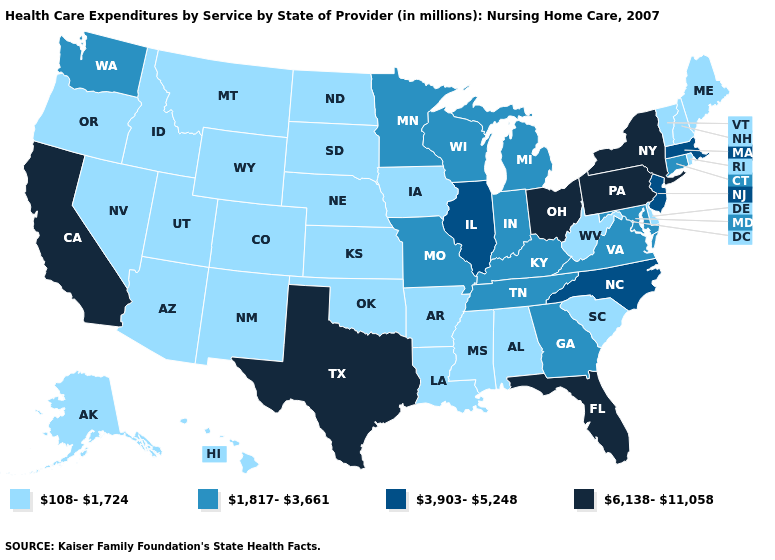Name the states that have a value in the range 6,138-11,058?
Write a very short answer. California, Florida, New York, Ohio, Pennsylvania, Texas. Which states hav the highest value in the Northeast?
Give a very brief answer. New York, Pennsylvania. Name the states that have a value in the range 3,903-5,248?
Short answer required. Illinois, Massachusetts, New Jersey, North Carolina. Does Kansas have the highest value in the MidWest?
Quick response, please. No. What is the value of Arkansas?
Quick response, please. 108-1,724. Which states have the highest value in the USA?
Give a very brief answer. California, Florida, New York, Ohio, Pennsylvania, Texas. Name the states that have a value in the range 3,903-5,248?
Write a very short answer. Illinois, Massachusetts, New Jersey, North Carolina. What is the lowest value in states that border Oklahoma?
Answer briefly. 108-1,724. Name the states that have a value in the range 1,817-3,661?
Be succinct. Connecticut, Georgia, Indiana, Kentucky, Maryland, Michigan, Minnesota, Missouri, Tennessee, Virginia, Washington, Wisconsin. Does California have the highest value in the West?
Give a very brief answer. Yes. What is the lowest value in the USA?
Quick response, please. 108-1,724. Among the states that border Utah , which have the lowest value?
Concise answer only. Arizona, Colorado, Idaho, Nevada, New Mexico, Wyoming. Which states hav the highest value in the South?
Short answer required. Florida, Texas. What is the value of North Dakota?
Be succinct. 108-1,724. Name the states that have a value in the range 108-1,724?
Keep it brief. Alabama, Alaska, Arizona, Arkansas, Colorado, Delaware, Hawaii, Idaho, Iowa, Kansas, Louisiana, Maine, Mississippi, Montana, Nebraska, Nevada, New Hampshire, New Mexico, North Dakota, Oklahoma, Oregon, Rhode Island, South Carolina, South Dakota, Utah, Vermont, West Virginia, Wyoming. 